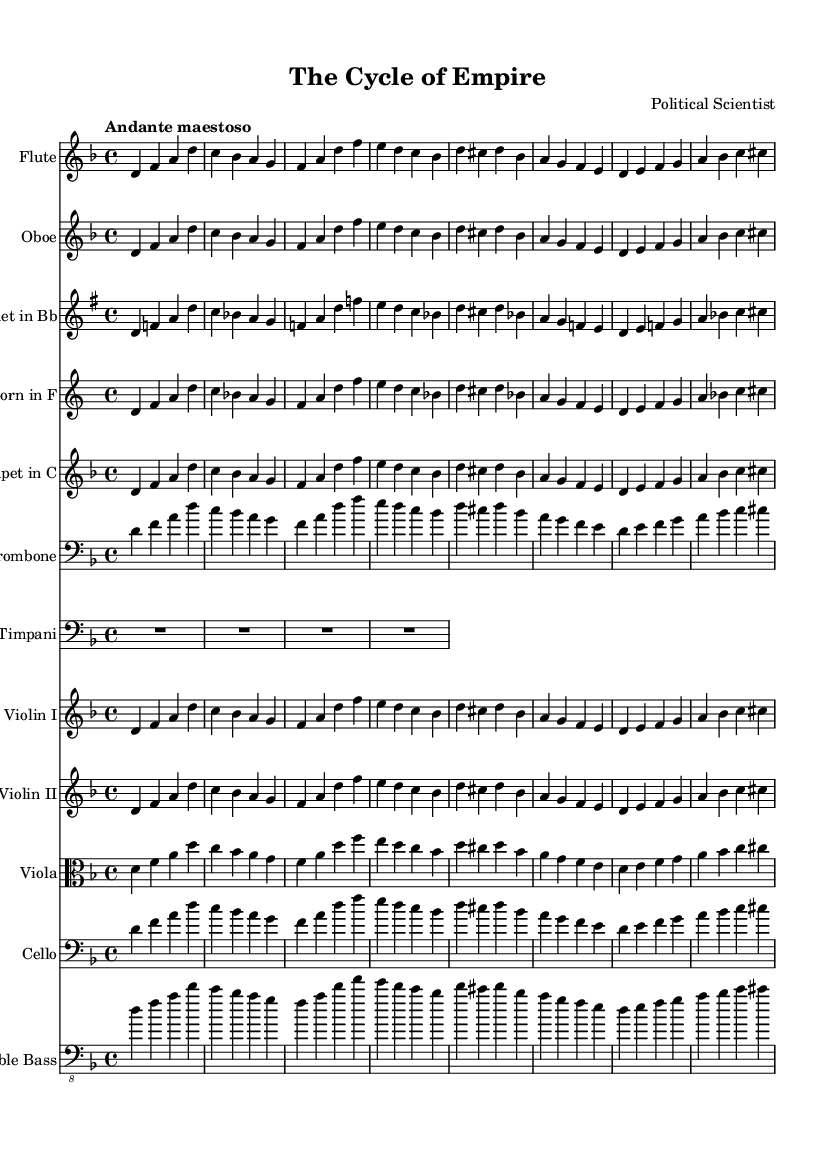What is the key signature of this symphony? The key signature is D minor, which has one flat (B♭). This is indicated by the key signature at the beginning of the staff.
Answer: D minor What is the time signature of this piece? The time signature is 4/4, shown at the start of the score. This means there are four beats in each measure and the quarter note gets one beat.
Answer: 4/4 What is the tempo marking for this composition? The tempo marking is "Andante maestoso," which signifies a moderately slow pace with a majestic character. This is typically found above the staff before the music begins.
Answer: Andante maestoso How many instruments are included in this symphony? The score includes twelve different instruments based on the number of individual staves, representing each instrument’s part.
Answer: Twelve Which musical theme is represented by the first melodic line in the Flute part? The first melodic line in the Flute part represents the theme of "rise of power." This can be identified by the initial notes played before transitioning into the next theme of corruption.
Answer: Rise of power What is the significance of the inclusion of Timpani in this symphony? The Timpani, found in the percussion section, typically provide a strong harmonic foundation and emphasize dramatic moments. In this case, Timpani is strategically placed to support the overarching themes of power and corruption in the piece.
Answer: Dramatic emphasis Which instrument is transposed when playing the Clarinet part? The Clarinet in B♭ is transposed up a major second to accommodate the writing in the score, indicated by the "\transpose" command. This means that what is written is played two steps higher than it appears in the score.
Answer: Up a major second 